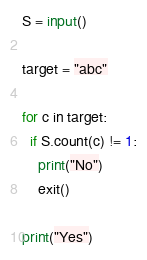<code> <loc_0><loc_0><loc_500><loc_500><_Python_>S = input()

target = "abc"

for c in target:
  if S.count(c) != 1:
    print("No")
    exit()

print("Yes")
</code> 